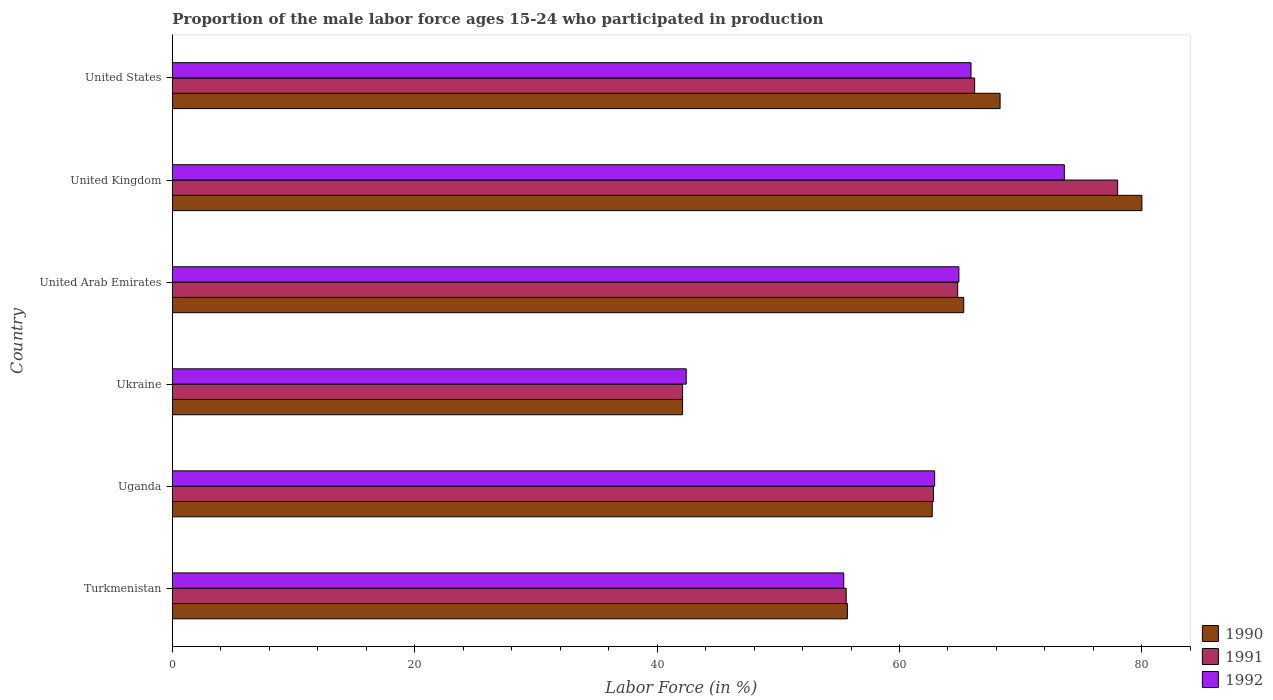How many different coloured bars are there?
Keep it short and to the point. 3. How many bars are there on the 3rd tick from the top?
Offer a terse response. 3. In how many cases, is the number of bars for a given country not equal to the number of legend labels?
Offer a terse response. 0. What is the proportion of the male labor force who participated in production in 1990 in United Kingdom?
Give a very brief answer. 80. Across all countries, what is the minimum proportion of the male labor force who participated in production in 1990?
Your answer should be compact. 42.1. In which country was the proportion of the male labor force who participated in production in 1991 minimum?
Offer a terse response. Ukraine. What is the total proportion of the male labor force who participated in production in 1991 in the graph?
Keep it short and to the point. 369.5. What is the difference between the proportion of the male labor force who participated in production in 1992 in Uganda and the proportion of the male labor force who participated in production in 1991 in United Arab Emirates?
Offer a very short reply. -1.9. What is the average proportion of the male labor force who participated in production in 1992 per country?
Offer a very short reply. 60.85. What is the difference between the proportion of the male labor force who participated in production in 1992 and proportion of the male labor force who participated in production in 1991 in Ukraine?
Your response must be concise. 0.3. In how many countries, is the proportion of the male labor force who participated in production in 1991 greater than 24 %?
Ensure brevity in your answer.  6. What is the ratio of the proportion of the male labor force who participated in production in 1992 in Ukraine to that in United Kingdom?
Your answer should be very brief. 0.58. Is the proportion of the male labor force who participated in production in 1991 in Turkmenistan less than that in Uganda?
Your answer should be very brief. Yes. Is the difference between the proportion of the male labor force who participated in production in 1992 in Ukraine and United States greater than the difference between the proportion of the male labor force who participated in production in 1991 in Ukraine and United States?
Give a very brief answer. Yes. What is the difference between the highest and the second highest proportion of the male labor force who participated in production in 1992?
Keep it short and to the point. 7.7. What is the difference between the highest and the lowest proportion of the male labor force who participated in production in 1990?
Ensure brevity in your answer.  37.9. In how many countries, is the proportion of the male labor force who participated in production in 1991 greater than the average proportion of the male labor force who participated in production in 1991 taken over all countries?
Offer a terse response. 4. What does the 1st bar from the top in Turkmenistan represents?
Make the answer very short. 1992. What does the 3rd bar from the bottom in Turkmenistan represents?
Offer a terse response. 1992. How many countries are there in the graph?
Your response must be concise. 6. What is the difference between two consecutive major ticks on the X-axis?
Your answer should be very brief. 20. Are the values on the major ticks of X-axis written in scientific E-notation?
Provide a short and direct response. No. Does the graph contain any zero values?
Offer a terse response. No. Does the graph contain grids?
Give a very brief answer. No. Where does the legend appear in the graph?
Ensure brevity in your answer.  Bottom right. What is the title of the graph?
Give a very brief answer. Proportion of the male labor force ages 15-24 who participated in production. What is the Labor Force (in %) of 1990 in Turkmenistan?
Give a very brief answer. 55.7. What is the Labor Force (in %) in 1991 in Turkmenistan?
Ensure brevity in your answer.  55.6. What is the Labor Force (in %) in 1992 in Turkmenistan?
Provide a short and direct response. 55.4. What is the Labor Force (in %) of 1990 in Uganda?
Your answer should be very brief. 62.7. What is the Labor Force (in %) in 1991 in Uganda?
Your answer should be compact. 62.8. What is the Labor Force (in %) of 1992 in Uganda?
Ensure brevity in your answer.  62.9. What is the Labor Force (in %) in 1990 in Ukraine?
Keep it short and to the point. 42.1. What is the Labor Force (in %) in 1991 in Ukraine?
Offer a terse response. 42.1. What is the Labor Force (in %) of 1992 in Ukraine?
Offer a terse response. 42.4. What is the Labor Force (in %) of 1990 in United Arab Emirates?
Keep it short and to the point. 65.3. What is the Labor Force (in %) of 1991 in United Arab Emirates?
Provide a succinct answer. 64.8. What is the Labor Force (in %) of 1992 in United Arab Emirates?
Offer a terse response. 64.9. What is the Labor Force (in %) in 1991 in United Kingdom?
Offer a terse response. 78. What is the Labor Force (in %) in 1992 in United Kingdom?
Your answer should be compact. 73.6. What is the Labor Force (in %) of 1990 in United States?
Give a very brief answer. 68.3. What is the Labor Force (in %) of 1991 in United States?
Keep it short and to the point. 66.2. What is the Labor Force (in %) of 1992 in United States?
Your answer should be compact. 65.9. Across all countries, what is the maximum Labor Force (in %) in 1990?
Provide a succinct answer. 80. Across all countries, what is the maximum Labor Force (in %) in 1991?
Offer a very short reply. 78. Across all countries, what is the maximum Labor Force (in %) in 1992?
Provide a succinct answer. 73.6. Across all countries, what is the minimum Labor Force (in %) in 1990?
Offer a terse response. 42.1. Across all countries, what is the minimum Labor Force (in %) of 1991?
Provide a short and direct response. 42.1. Across all countries, what is the minimum Labor Force (in %) of 1992?
Give a very brief answer. 42.4. What is the total Labor Force (in %) of 1990 in the graph?
Make the answer very short. 374.1. What is the total Labor Force (in %) of 1991 in the graph?
Offer a very short reply. 369.5. What is the total Labor Force (in %) of 1992 in the graph?
Ensure brevity in your answer.  365.1. What is the difference between the Labor Force (in %) of 1992 in Turkmenistan and that in Ukraine?
Offer a terse response. 13. What is the difference between the Labor Force (in %) of 1991 in Turkmenistan and that in United Arab Emirates?
Keep it short and to the point. -9.2. What is the difference between the Labor Force (in %) of 1992 in Turkmenistan and that in United Arab Emirates?
Your response must be concise. -9.5. What is the difference between the Labor Force (in %) in 1990 in Turkmenistan and that in United Kingdom?
Keep it short and to the point. -24.3. What is the difference between the Labor Force (in %) of 1991 in Turkmenistan and that in United Kingdom?
Your answer should be compact. -22.4. What is the difference between the Labor Force (in %) of 1992 in Turkmenistan and that in United Kingdom?
Offer a very short reply. -18.2. What is the difference between the Labor Force (in %) in 1990 in Turkmenistan and that in United States?
Keep it short and to the point. -12.6. What is the difference between the Labor Force (in %) in 1990 in Uganda and that in Ukraine?
Provide a succinct answer. 20.6. What is the difference between the Labor Force (in %) of 1991 in Uganda and that in Ukraine?
Provide a succinct answer. 20.7. What is the difference between the Labor Force (in %) of 1992 in Uganda and that in Ukraine?
Ensure brevity in your answer.  20.5. What is the difference between the Labor Force (in %) in 1991 in Uganda and that in United Arab Emirates?
Your answer should be compact. -2. What is the difference between the Labor Force (in %) of 1992 in Uganda and that in United Arab Emirates?
Offer a terse response. -2. What is the difference between the Labor Force (in %) of 1990 in Uganda and that in United Kingdom?
Ensure brevity in your answer.  -17.3. What is the difference between the Labor Force (in %) in 1991 in Uganda and that in United Kingdom?
Give a very brief answer. -15.2. What is the difference between the Labor Force (in %) in 1992 in Uganda and that in United Kingdom?
Make the answer very short. -10.7. What is the difference between the Labor Force (in %) in 1990 in Uganda and that in United States?
Your response must be concise. -5.6. What is the difference between the Labor Force (in %) of 1991 in Uganda and that in United States?
Provide a succinct answer. -3.4. What is the difference between the Labor Force (in %) in 1992 in Uganda and that in United States?
Provide a succinct answer. -3. What is the difference between the Labor Force (in %) of 1990 in Ukraine and that in United Arab Emirates?
Your answer should be very brief. -23.2. What is the difference between the Labor Force (in %) in 1991 in Ukraine and that in United Arab Emirates?
Provide a succinct answer. -22.7. What is the difference between the Labor Force (in %) of 1992 in Ukraine and that in United Arab Emirates?
Give a very brief answer. -22.5. What is the difference between the Labor Force (in %) of 1990 in Ukraine and that in United Kingdom?
Keep it short and to the point. -37.9. What is the difference between the Labor Force (in %) in 1991 in Ukraine and that in United Kingdom?
Offer a terse response. -35.9. What is the difference between the Labor Force (in %) in 1992 in Ukraine and that in United Kingdom?
Make the answer very short. -31.2. What is the difference between the Labor Force (in %) of 1990 in Ukraine and that in United States?
Your answer should be very brief. -26.2. What is the difference between the Labor Force (in %) of 1991 in Ukraine and that in United States?
Give a very brief answer. -24.1. What is the difference between the Labor Force (in %) in 1992 in Ukraine and that in United States?
Ensure brevity in your answer.  -23.5. What is the difference between the Labor Force (in %) in 1990 in United Arab Emirates and that in United Kingdom?
Your response must be concise. -14.7. What is the difference between the Labor Force (in %) of 1992 in United Arab Emirates and that in United Kingdom?
Your response must be concise. -8.7. What is the difference between the Labor Force (in %) of 1990 in United Arab Emirates and that in United States?
Offer a terse response. -3. What is the difference between the Labor Force (in %) in 1991 in United Arab Emirates and that in United States?
Offer a very short reply. -1.4. What is the difference between the Labor Force (in %) in 1992 in United Arab Emirates and that in United States?
Offer a very short reply. -1. What is the difference between the Labor Force (in %) of 1990 in Turkmenistan and the Labor Force (in %) of 1992 in Uganda?
Give a very brief answer. -7.2. What is the difference between the Labor Force (in %) of 1991 in Turkmenistan and the Labor Force (in %) of 1992 in Uganda?
Provide a succinct answer. -7.3. What is the difference between the Labor Force (in %) of 1990 in Turkmenistan and the Labor Force (in %) of 1992 in United Arab Emirates?
Ensure brevity in your answer.  -9.2. What is the difference between the Labor Force (in %) in 1990 in Turkmenistan and the Labor Force (in %) in 1991 in United Kingdom?
Make the answer very short. -22.3. What is the difference between the Labor Force (in %) of 1990 in Turkmenistan and the Labor Force (in %) of 1992 in United Kingdom?
Provide a succinct answer. -17.9. What is the difference between the Labor Force (in %) of 1991 in Turkmenistan and the Labor Force (in %) of 1992 in United Kingdom?
Give a very brief answer. -18. What is the difference between the Labor Force (in %) of 1990 in Uganda and the Labor Force (in %) of 1991 in Ukraine?
Give a very brief answer. 20.6. What is the difference between the Labor Force (in %) in 1990 in Uganda and the Labor Force (in %) in 1992 in Ukraine?
Offer a very short reply. 20.3. What is the difference between the Labor Force (in %) in 1991 in Uganda and the Labor Force (in %) in 1992 in Ukraine?
Your answer should be compact. 20.4. What is the difference between the Labor Force (in %) in 1990 in Uganda and the Labor Force (in %) in 1991 in United Arab Emirates?
Offer a terse response. -2.1. What is the difference between the Labor Force (in %) in 1990 in Uganda and the Labor Force (in %) in 1991 in United Kingdom?
Make the answer very short. -15.3. What is the difference between the Labor Force (in %) of 1990 in Uganda and the Labor Force (in %) of 1992 in United Kingdom?
Ensure brevity in your answer.  -10.9. What is the difference between the Labor Force (in %) in 1991 in Uganda and the Labor Force (in %) in 1992 in United Kingdom?
Provide a short and direct response. -10.8. What is the difference between the Labor Force (in %) in 1991 in Uganda and the Labor Force (in %) in 1992 in United States?
Offer a terse response. -3.1. What is the difference between the Labor Force (in %) in 1990 in Ukraine and the Labor Force (in %) in 1991 in United Arab Emirates?
Your answer should be very brief. -22.7. What is the difference between the Labor Force (in %) of 1990 in Ukraine and the Labor Force (in %) of 1992 in United Arab Emirates?
Keep it short and to the point. -22.8. What is the difference between the Labor Force (in %) of 1991 in Ukraine and the Labor Force (in %) of 1992 in United Arab Emirates?
Ensure brevity in your answer.  -22.8. What is the difference between the Labor Force (in %) in 1990 in Ukraine and the Labor Force (in %) in 1991 in United Kingdom?
Your response must be concise. -35.9. What is the difference between the Labor Force (in %) in 1990 in Ukraine and the Labor Force (in %) in 1992 in United Kingdom?
Make the answer very short. -31.5. What is the difference between the Labor Force (in %) of 1991 in Ukraine and the Labor Force (in %) of 1992 in United Kingdom?
Give a very brief answer. -31.5. What is the difference between the Labor Force (in %) of 1990 in Ukraine and the Labor Force (in %) of 1991 in United States?
Your answer should be very brief. -24.1. What is the difference between the Labor Force (in %) of 1990 in Ukraine and the Labor Force (in %) of 1992 in United States?
Ensure brevity in your answer.  -23.8. What is the difference between the Labor Force (in %) of 1991 in Ukraine and the Labor Force (in %) of 1992 in United States?
Ensure brevity in your answer.  -23.8. What is the difference between the Labor Force (in %) of 1990 in United Arab Emirates and the Labor Force (in %) of 1991 in United Kingdom?
Provide a short and direct response. -12.7. What is the difference between the Labor Force (in %) in 1990 in United Arab Emirates and the Labor Force (in %) in 1992 in United States?
Provide a short and direct response. -0.6. What is the difference between the Labor Force (in %) of 1991 in United Arab Emirates and the Labor Force (in %) of 1992 in United States?
Give a very brief answer. -1.1. What is the average Labor Force (in %) of 1990 per country?
Provide a short and direct response. 62.35. What is the average Labor Force (in %) in 1991 per country?
Offer a terse response. 61.58. What is the average Labor Force (in %) in 1992 per country?
Your response must be concise. 60.85. What is the difference between the Labor Force (in %) in 1990 and Labor Force (in %) in 1991 in Turkmenistan?
Your answer should be very brief. 0.1. What is the difference between the Labor Force (in %) of 1990 and Labor Force (in %) of 1991 in Uganda?
Your answer should be compact. -0.1. What is the difference between the Labor Force (in %) of 1990 and Labor Force (in %) of 1992 in Uganda?
Make the answer very short. -0.2. What is the difference between the Labor Force (in %) of 1990 and Labor Force (in %) of 1992 in Ukraine?
Ensure brevity in your answer.  -0.3. What is the difference between the Labor Force (in %) of 1991 and Labor Force (in %) of 1992 in Ukraine?
Your response must be concise. -0.3. What is the difference between the Labor Force (in %) of 1991 and Labor Force (in %) of 1992 in United Arab Emirates?
Provide a succinct answer. -0.1. What is the difference between the Labor Force (in %) in 1990 and Labor Force (in %) in 1992 in United Kingdom?
Your answer should be compact. 6.4. What is the difference between the Labor Force (in %) in 1991 and Labor Force (in %) in 1992 in United Kingdom?
Make the answer very short. 4.4. What is the difference between the Labor Force (in %) in 1990 and Labor Force (in %) in 1991 in United States?
Ensure brevity in your answer.  2.1. What is the difference between the Labor Force (in %) of 1990 and Labor Force (in %) of 1992 in United States?
Provide a succinct answer. 2.4. What is the difference between the Labor Force (in %) of 1991 and Labor Force (in %) of 1992 in United States?
Make the answer very short. 0.3. What is the ratio of the Labor Force (in %) in 1990 in Turkmenistan to that in Uganda?
Offer a terse response. 0.89. What is the ratio of the Labor Force (in %) of 1991 in Turkmenistan to that in Uganda?
Ensure brevity in your answer.  0.89. What is the ratio of the Labor Force (in %) of 1992 in Turkmenistan to that in Uganda?
Give a very brief answer. 0.88. What is the ratio of the Labor Force (in %) in 1990 in Turkmenistan to that in Ukraine?
Keep it short and to the point. 1.32. What is the ratio of the Labor Force (in %) in 1991 in Turkmenistan to that in Ukraine?
Provide a succinct answer. 1.32. What is the ratio of the Labor Force (in %) in 1992 in Turkmenistan to that in Ukraine?
Keep it short and to the point. 1.31. What is the ratio of the Labor Force (in %) in 1990 in Turkmenistan to that in United Arab Emirates?
Your answer should be compact. 0.85. What is the ratio of the Labor Force (in %) in 1991 in Turkmenistan to that in United Arab Emirates?
Your answer should be very brief. 0.86. What is the ratio of the Labor Force (in %) of 1992 in Turkmenistan to that in United Arab Emirates?
Provide a short and direct response. 0.85. What is the ratio of the Labor Force (in %) of 1990 in Turkmenistan to that in United Kingdom?
Offer a terse response. 0.7. What is the ratio of the Labor Force (in %) of 1991 in Turkmenistan to that in United Kingdom?
Give a very brief answer. 0.71. What is the ratio of the Labor Force (in %) of 1992 in Turkmenistan to that in United Kingdom?
Keep it short and to the point. 0.75. What is the ratio of the Labor Force (in %) of 1990 in Turkmenistan to that in United States?
Give a very brief answer. 0.82. What is the ratio of the Labor Force (in %) of 1991 in Turkmenistan to that in United States?
Offer a very short reply. 0.84. What is the ratio of the Labor Force (in %) in 1992 in Turkmenistan to that in United States?
Your answer should be very brief. 0.84. What is the ratio of the Labor Force (in %) of 1990 in Uganda to that in Ukraine?
Give a very brief answer. 1.49. What is the ratio of the Labor Force (in %) in 1991 in Uganda to that in Ukraine?
Give a very brief answer. 1.49. What is the ratio of the Labor Force (in %) of 1992 in Uganda to that in Ukraine?
Your answer should be compact. 1.48. What is the ratio of the Labor Force (in %) of 1990 in Uganda to that in United Arab Emirates?
Your response must be concise. 0.96. What is the ratio of the Labor Force (in %) in 1991 in Uganda to that in United Arab Emirates?
Make the answer very short. 0.97. What is the ratio of the Labor Force (in %) of 1992 in Uganda to that in United Arab Emirates?
Your answer should be compact. 0.97. What is the ratio of the Labor Force (in %) in 1990 in Uganda to that in United Kingdom?
Give a very brief answer. 0.78. What is the ratio of the Labor Force (in %) in 1991 in Uganda to that in United Kingdom?
Give a very brief answer. 0.81. What is the ratio of the Labor Force (in %) of 1992 in Uganda to that in United Kingdom?
Make the answer very short. 0.85. What is the ratio of the Labor Force (in %) in 1990 in Uganda to that in United States?
Provide a succinct answer. 0.92. What is the ratio of the Labor Force (in %) in 1991 in Uganda to that in United States?
Ensure brevity in your answer.  0.95. What is the ratio of the Labor Force (in %) in 1992 in Uganda to that in United States?
Provide a succinct answer. 0.95. What is the ratio of the Labor Force (in %) in 1990 in Ukraine to that in United Arab Emirates?
Offer a very short reply. 0.64. What is the ratio of the Labor Force (in %) of 1991 in Ukraine to that in United Arab Emirates?
Offer a terse response. 0.65. What is the ratio of the Labor Force (in %) in 1992 in Ukraine to that in United Arab Emirates?
Give a very brief answer. 0.65. What is the ratio of the Labor Force (in %) of 1990 in Ukraine to that in United Kingdom?
Offer a very short reply. 0.53. What is the ratio of the Labor Force (in %) of 1991 in Ukraine to that in United Kingdom?
Your response must be concise. 0.54. What is the ratio of the Labor Force (in %) of 1992 in Ukraine to that in United Kingdom?
Offer a terse response. 0.58. What is the ratio of the Labor Force (in %) of 1990 in Ukraine to that in United States?
Give a very brief answer. 0.62. What is the ratio of the Labor Force (in %) of 1991 in Ukraine to that in United States?
Offer a terse response. 0.64. What is the ratio of the Labor Force (in %) in 1992 in Ukraine to that in United States?
Your answer should be very brief. 0.64. What is the ratio of the Labor Force (in %) in 1990 in United Arab Emirates to that in United Kingdom?
Provide a short and direct response. 0.82. What is the ratio of the Labor Force (in %) of 1991 in United Arab Emirates to that in United Kingdom?
Keep it short and to the point. 0.83. What is the ratio of the Labor Force (in %) in 1992 in United Arab Emirates to that in United Kingdom?
Give a very brief answer. 0.88. What is the ratio of the Labor Force (in %) in 1990 in United Arab Emirates to that in United States?
Make the answer very short. 0.96. What is the ratio of the Labor Force (in %) of 1991 in United Arab Emirates to that in United States?
Make the answer very short. 0.98. What is the ratio of the Labor Force (in %) of 1990 in United Kingdom to that in United States?
Offer a terse response. 1.17. What is the ratio of the Labor Force (in %) in 1991 in United Kingdom to that in United States?
Provide a succinct answer. 1.18. What is the ratio of the Labor Force (in %) of 1992 in United Kingdom to that in United States?
Offer a terse response. 1.12. What is the difference between the highest and the second highest Labor Force (in %) of 1990?
Provide a short and direct response. 11.7. What is the difference between the highest and the lowest Labor Force (in %) in 1990?
Your response must be concise. 37.9. What is the difference between the highest and the lowest Labor Force (in %) in 1991?
Offer a very short reply. 35.9. What is the difference between the highest and the lowest Labor Force (in %) of 1992?
Make the answer very short. 31.2. 